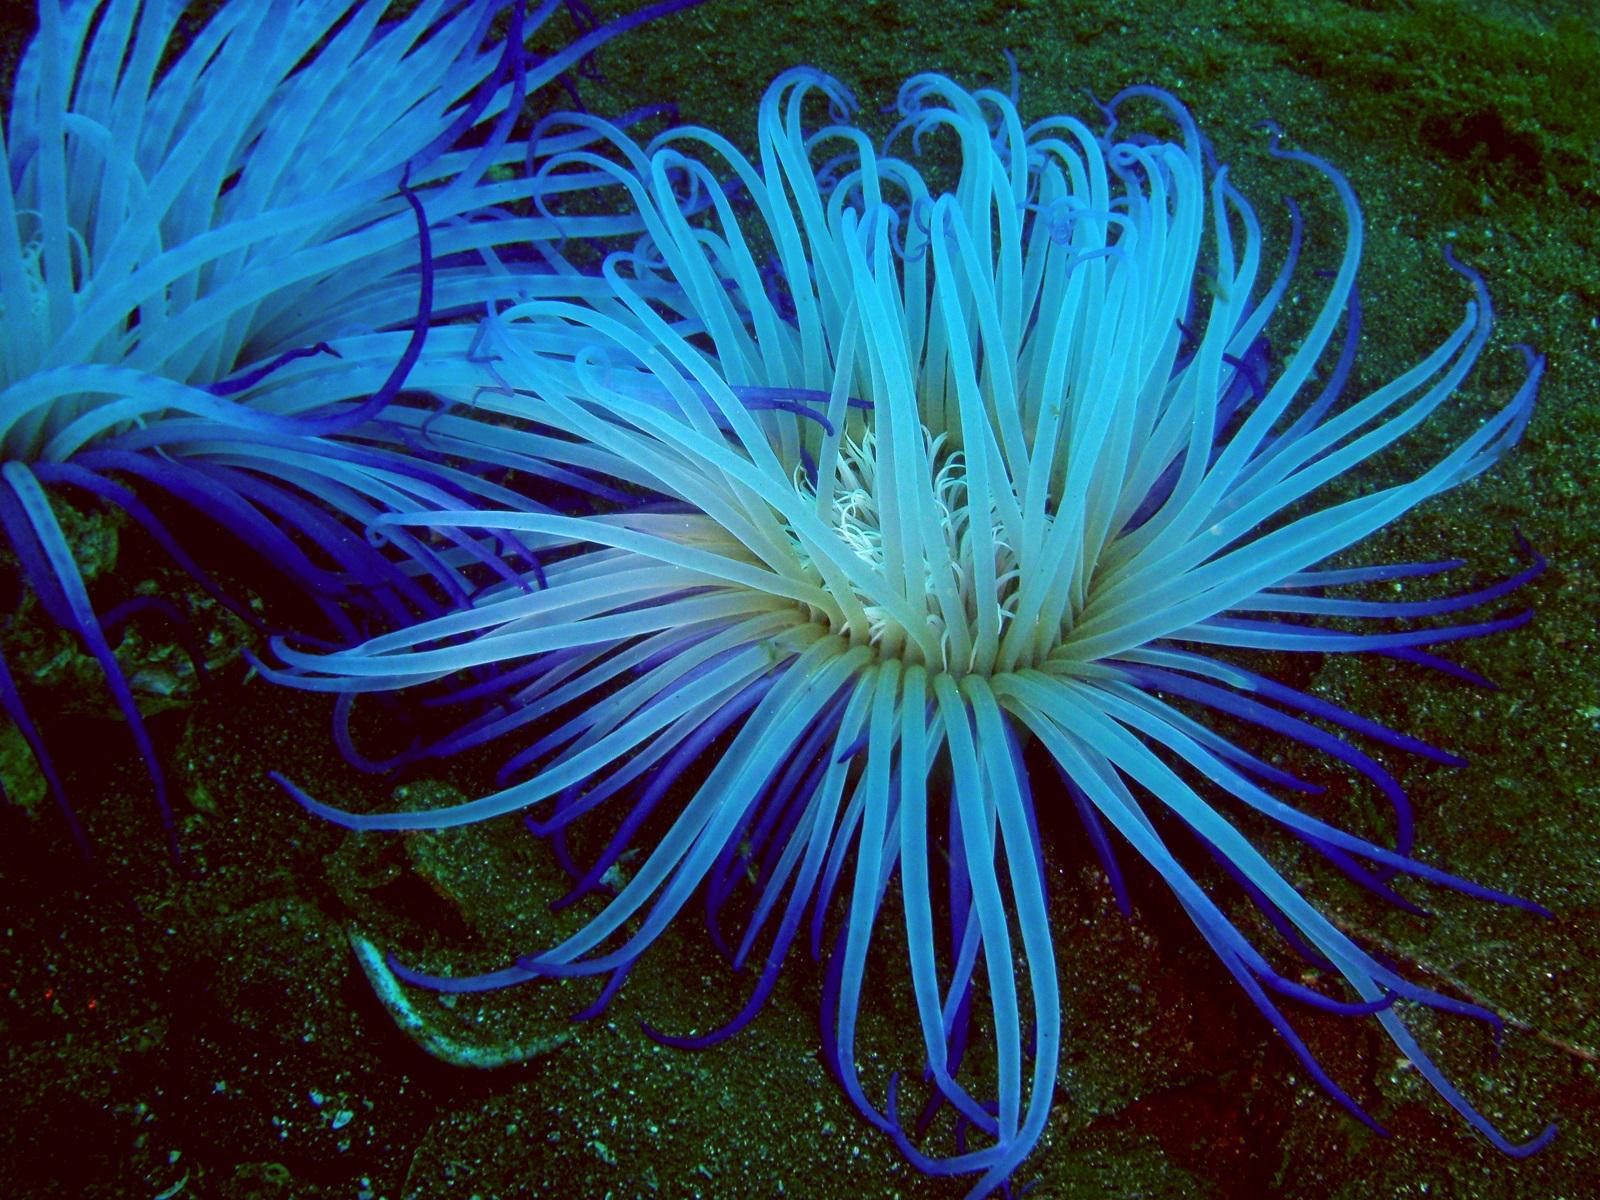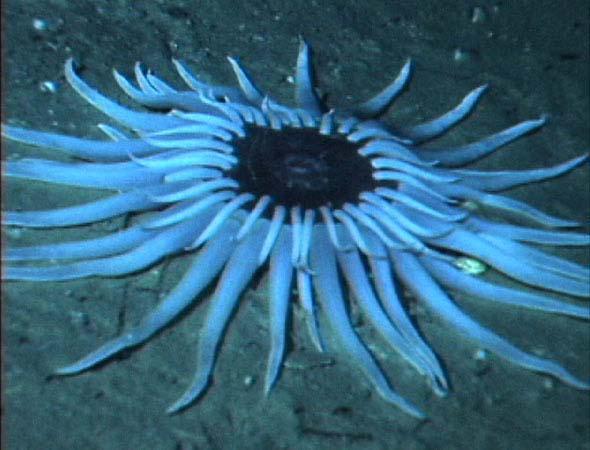The first image is the image on the left, the second image is the image on the right. Assess this claim about the two images: "in at least one image there is a coral reef piece that's circle is pink and has at least 20 pink arm looking pieces that come from the circle.". Correct or not? Answer yes or no. No. The first image is the image on the left, the second image is the image on the right. Given the left and right images, does the statement "Each image contains at least one prominent anemone with glowing bluish tint, but the lefthand anemone has a white center and deeper blue around the edges." hold true? Answer yes or no. Yes. 